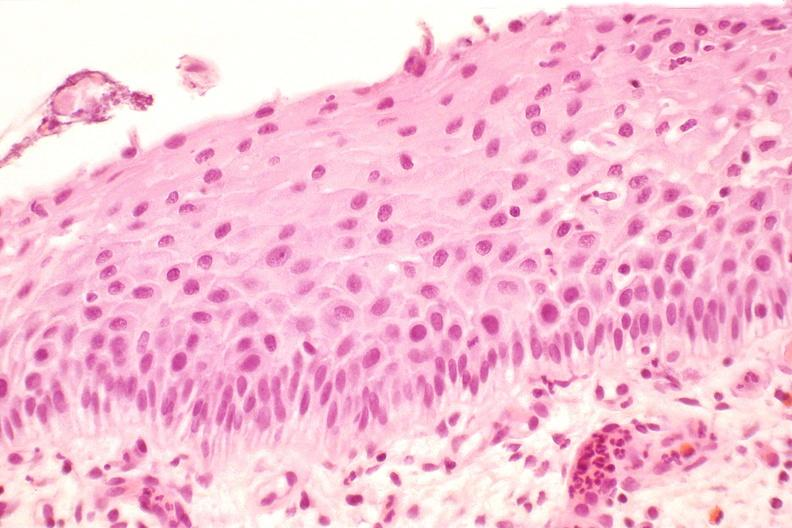what is present?
Answer the question using a single word or phrase. Female reproductive 